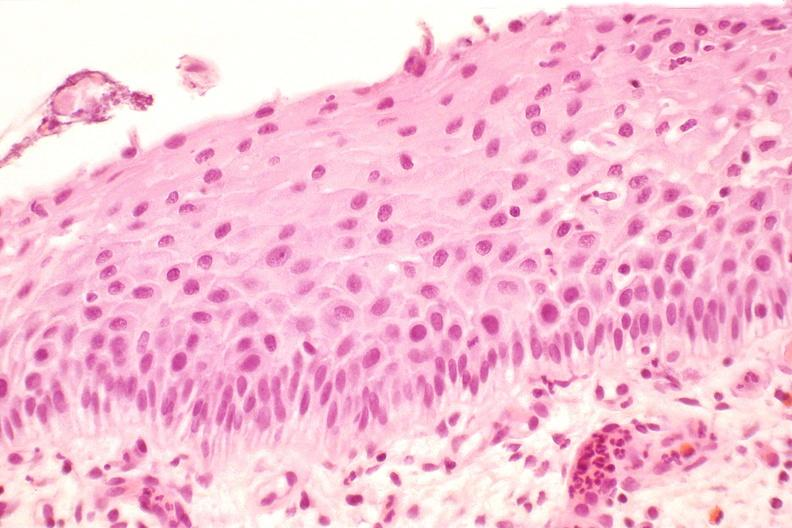what is present?
Answer the question using a single word or phrase. Female reproductive 